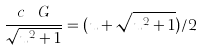Convert formula to latex. <formula><loc_0><loc_0><loc_500><loc_500>\frac { c _ { \ } G } { \sqrt { u ^ { 2 } + 1 } } = ( u + \sqrt { u ^ { 2 } + 1 } ) / 2</formula> 